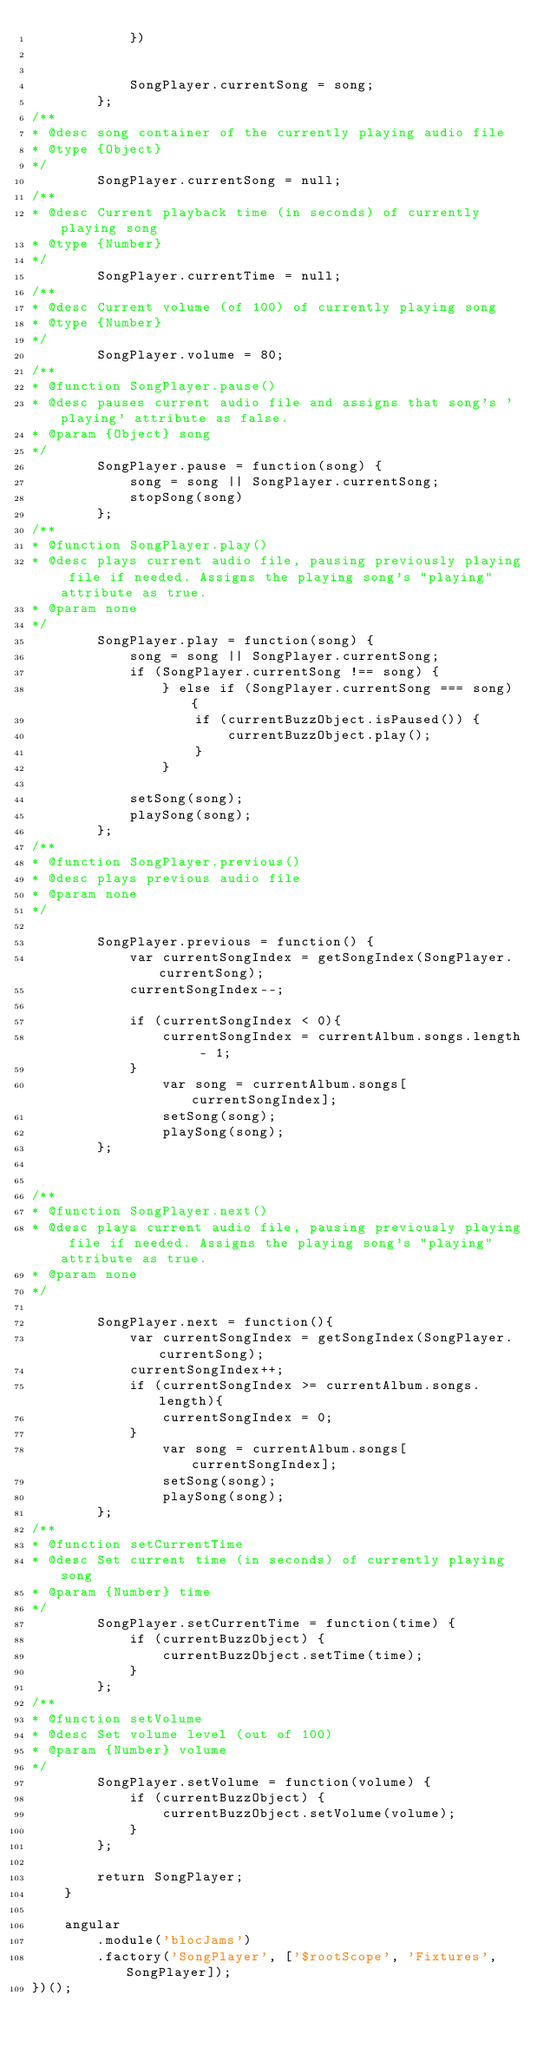Convert code to text. <code><loc_0><loc_0><loc_500><loc_500><_JavaScript_>            })
            
        
            SongPlayer.currentSong = song;  
        };
/**
* @desc song container of the currently playing audio file
* @type {Object}
*/ 
        SongPlayer.currentSong = null;
/**
* @desc Current playback time (in seconds) of currently playing song
* @type {Number}
*/
        SongPlayer.currentTime = null;
/**
* @desc Current volume (of 100) of currently playing song
* @type {Number}
*/     
        SongPlayer.volume = 80;
/**
* @function SongPlayer.pause()
* @desc pauses current audio file and assigns that song's 'playing' attribute as false.
* @param {Object} song
*/
        SongPlayer.pause = function(song) {
            song = song || SongPlayer.currentSong;
            stopSong(song)
        };
/**
* @function SongPlayer.play()
* @desc plays current audio file, pausing previously playing file if needed. Assigns the playing song's "playing" attribute as true. 
* @param none
*/        
        SongPlayer.play = function(song) {
            song = song || SongPlayer.currentSong;
            if (SongPlayer.currentSong !== song) {
                } else if (SongPlayer.currentSong === song) {
                    if (currentBuzzObject.isPaused()) {
                        currentBuzzObject.play();
                    }
                }
                
            setSong(song);
            playSong(song);
        };
/**
* @function SongPlayer.previous()
* @desc plays previous audio file
* @param none
*/ 
        
        SongPlayer.previous = function() {
            var currentSongIndex = getSongIndex(SongPlayer.currentSong);
            currentSongIndex--;
            
            if (currentSongIndex < 0){
                currentSongIndex = currentAlbum.songs.length - 1;
            } 
                var song = currentAlbum.songs[currentSongIndex];
                setSong(song);
                playSong(song);   
        };
        
    
/**
* @function SongPlayer.next()
* @desc plays current audio file, pausing previously playing file if needed. Assigns the playing song's "playing" attribute as true. 
* @param none
*/
    
        SongPlayer.next = function(){
            var currentSongIndex = getSongIndex(SongPlayer.currentSong);
            currentSongIndex++;
            if (currentSongIndex >= currentAlbum.songs.length){
                currentSongIndex = 0;
            } 
                var song = currentAlbum.songs[currentSongIndex];
                setSong(song);
                playSong(song);
        };
/**
* @function setCurrentTime
* @desc Set current time (in seconds) of currently playing song
* @param {Number} time
*/
        SongPlayer.setCurrentTime = function(time) {
            if (currentBuzzObject) {
                currentBuzzObject.setTime(time);
            }
        };
/**
* @function setVolume
* @desc Set volume level (out of 100)
* @param {Number} volume
*/
        SongPlayer.setVolume = function(volume) {
            if (currentBuzzObject) {
                currentBuzzObject.setVolume(volume);
            }
        };
        
        return SongPlayer;
    }
    
    angular
        .module('blocJams')
        .factory('SongPlayer', ['$rootScope', 'Fixtures', SongPlayer]);
})();</code> 